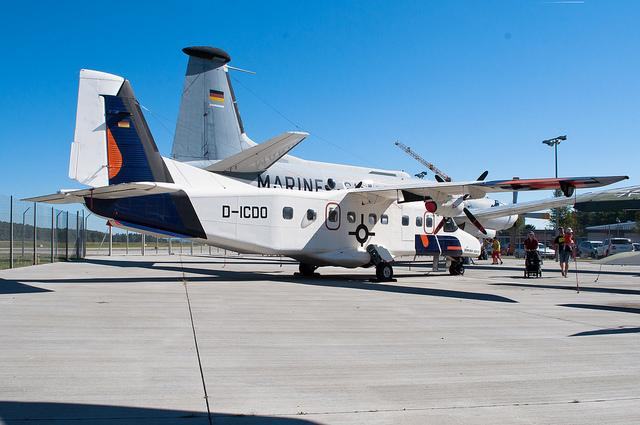What top speed can this vehicle likely reach? 300 mph 